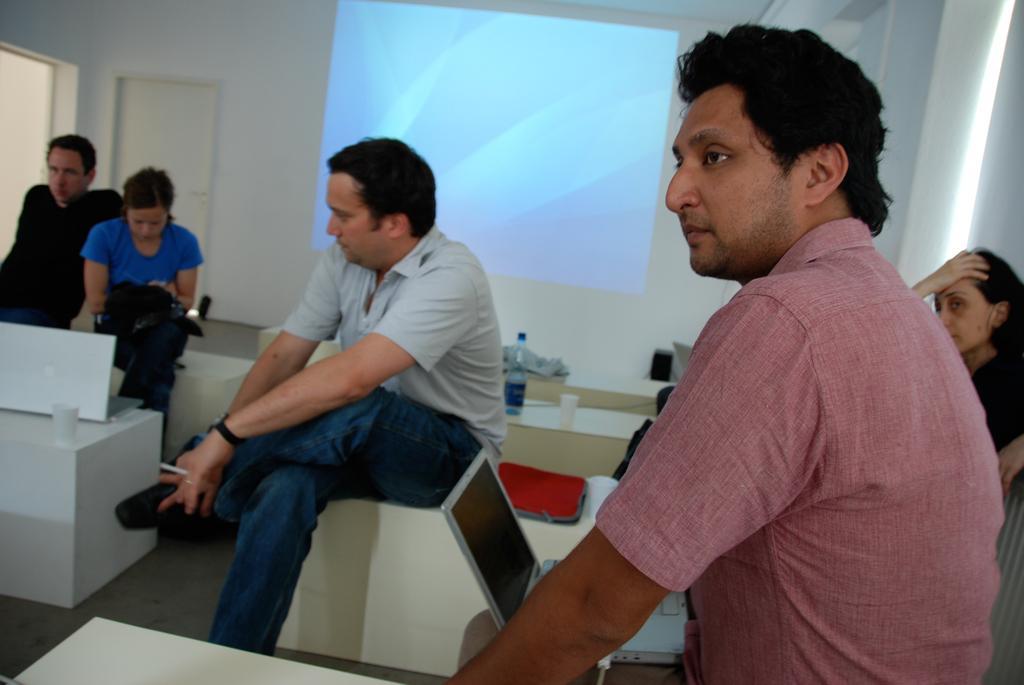Could you give a brief overview of what you see in this image? In this image we can see a group of people sitting on chairs. In the foreground we can see a laptop with cable. In the center of the image we can see the bottle, cap and a bag placed on a chair. In the left side of the image we can see a laptop and cup placed on the table. In the background, we can see a screen, door and window. 